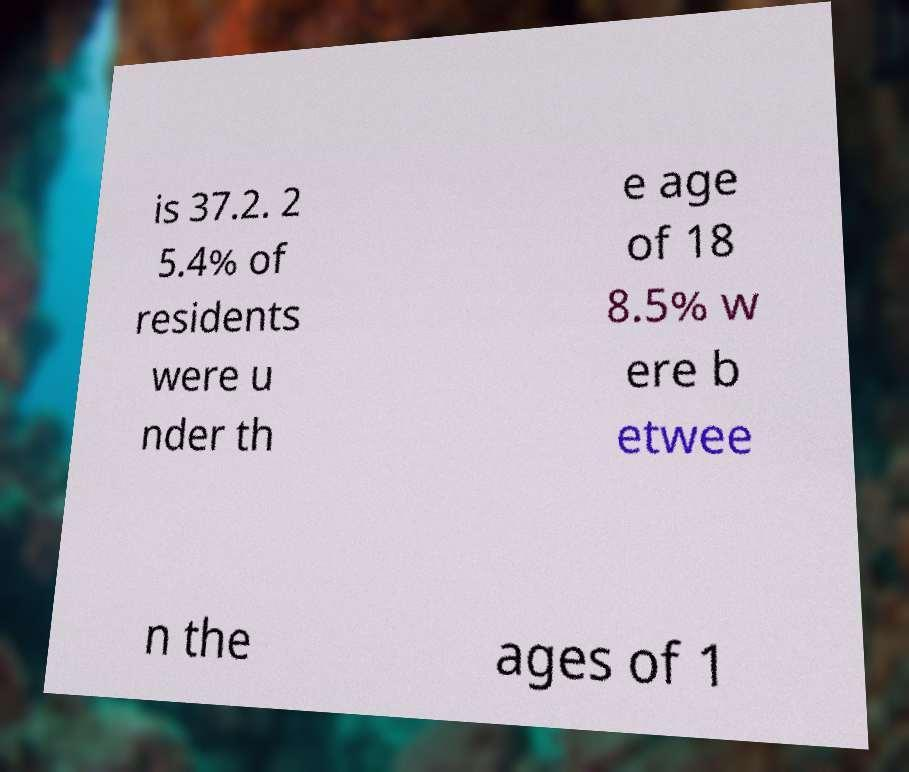I need the written content from this picture converted into text. Can you do that? is 37.2. 2 5.4% of residents were u nder th e age of 18 8.5% w ere b etwee n the ages of 1 